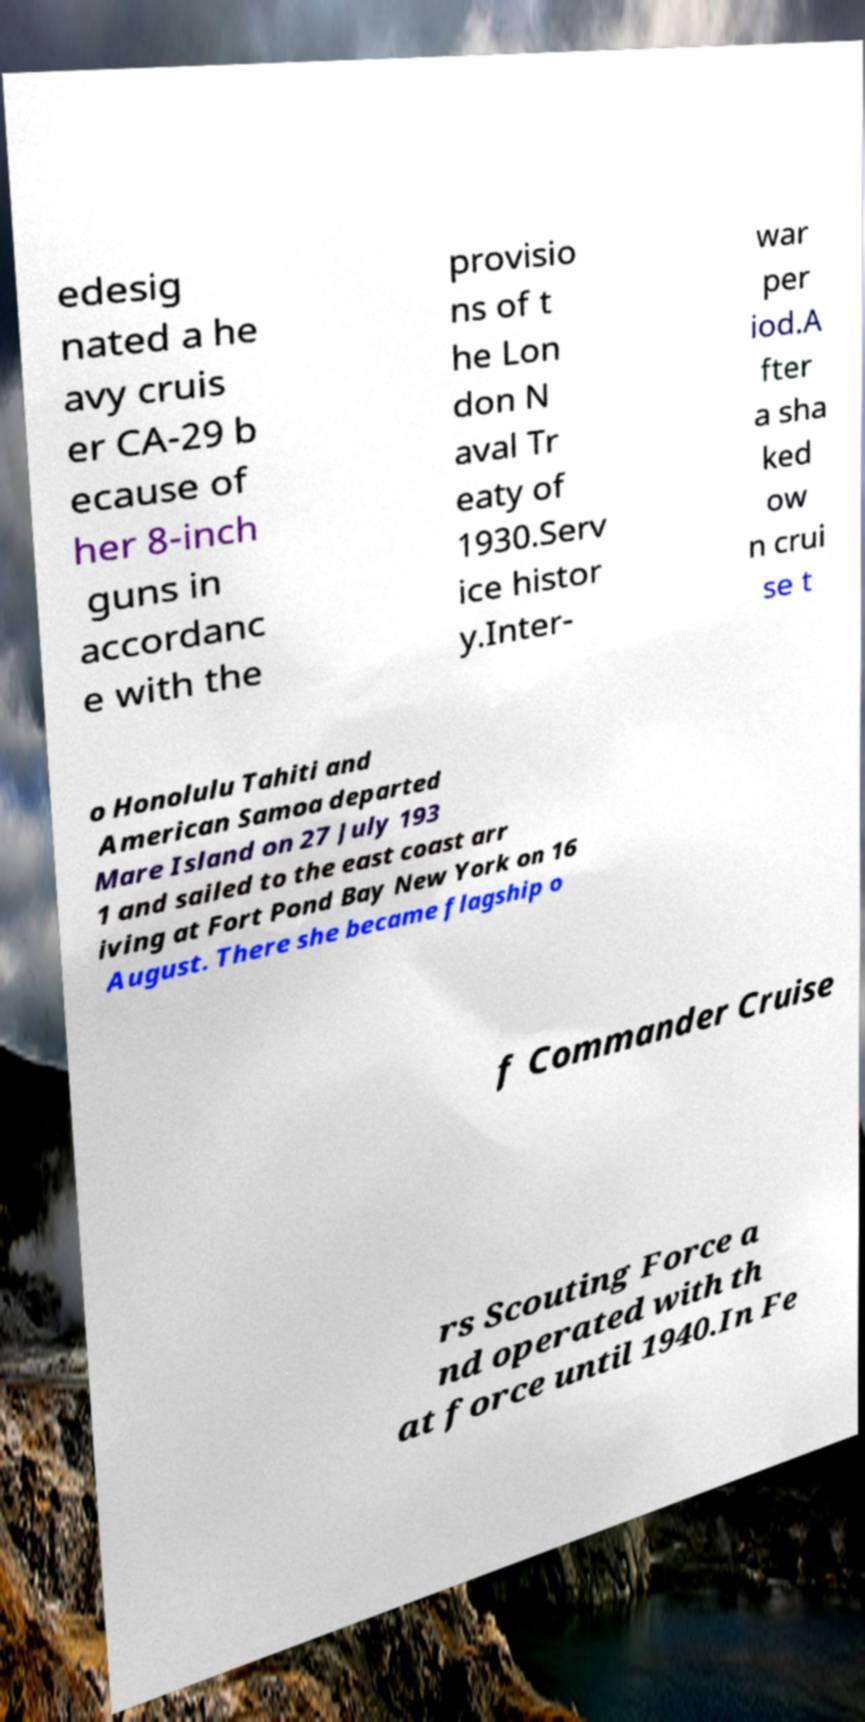Can you read and provide the text displayed in the image?This photo seems to have some interesting text. Can you extract and type it out for me? edesig nated a he avy cruis er CA-29 b ecause of her 8-inch guns in accordanc e with the provisio ns of t he Lon don N aval Tr eaty of 1930.Serv ice histor y.Inter- war per iod.A fter a sha ked ow n crui se t o Honolulu Tahiti and American Samoa departed Mare Island on 27 July 193 1 and sailed to the east coast arr iving at Fort Pond Bay New York on 16 August. There she became flagship o f Commander Cruise rs Scouting Force a nd operated with th at force until 1940.In Fe 